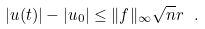Convert formula to latex. <formula><loc_0><loc_0><loc_500><loc_500>| u ( t ) | - | u _ { 0 } | \leq \| f \| _ { \infty } \sqrt { n } r \ .</formula> 